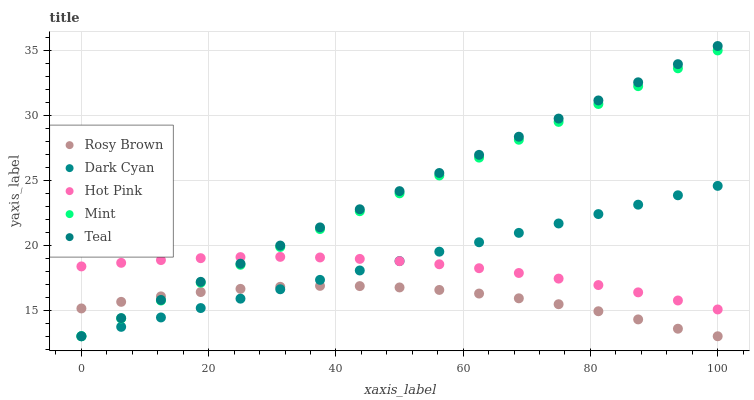Does Rosy Brown have the minimum area under the curve?
Answer yes or no. Yes. Does Teal have the maximum area under the curve?
Answer yes or no. Yes. Does Mint have the minimum area under the curve?
Answer yes or no. No. Does Mint have the maximum area under the curve?
Answer yes or no. No. Is Teal the smoothest?
Answer yes or no. Yes. Is Rosy Brown the roughest?
Answer yes or no. Yes. Is Mint the smoothest?
Answer yes or no. No. Is Mint the roughest?
Answer yes or no. No. Does Dark Cyan have the lowest value?
Answer yes or no. Yes. Does Hot Pink have the lowest value?
Answer yes or no. No. Does Teal have the highest value?
Answer yes or no. Yes. Does Mint have the highest value?
Answer yes or no. No. Is Rosy Brown less than Hot Pink?
Answer yes or no. Yes. Is Hot Pink greater than Rosy Brown?
Answer yes or no. Yes. Does Dark Cyan intersect Hot Pink?
Answer yes or no. Yes. Is Dark Cyan less than Hot Pink?
Answer yes or no. No. Is Dark Cyan greater than Hot Pink?
Answer yes or no. No. Does Rosy Brown intersect Hot Pink?
Answer yes or no. No. 